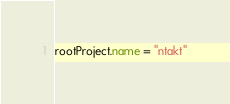Convert code to text. <code><loc_0><loc_0><loc_500><loc_500><_Kotlin_>rootProject.name = "ntakt"

</code> 